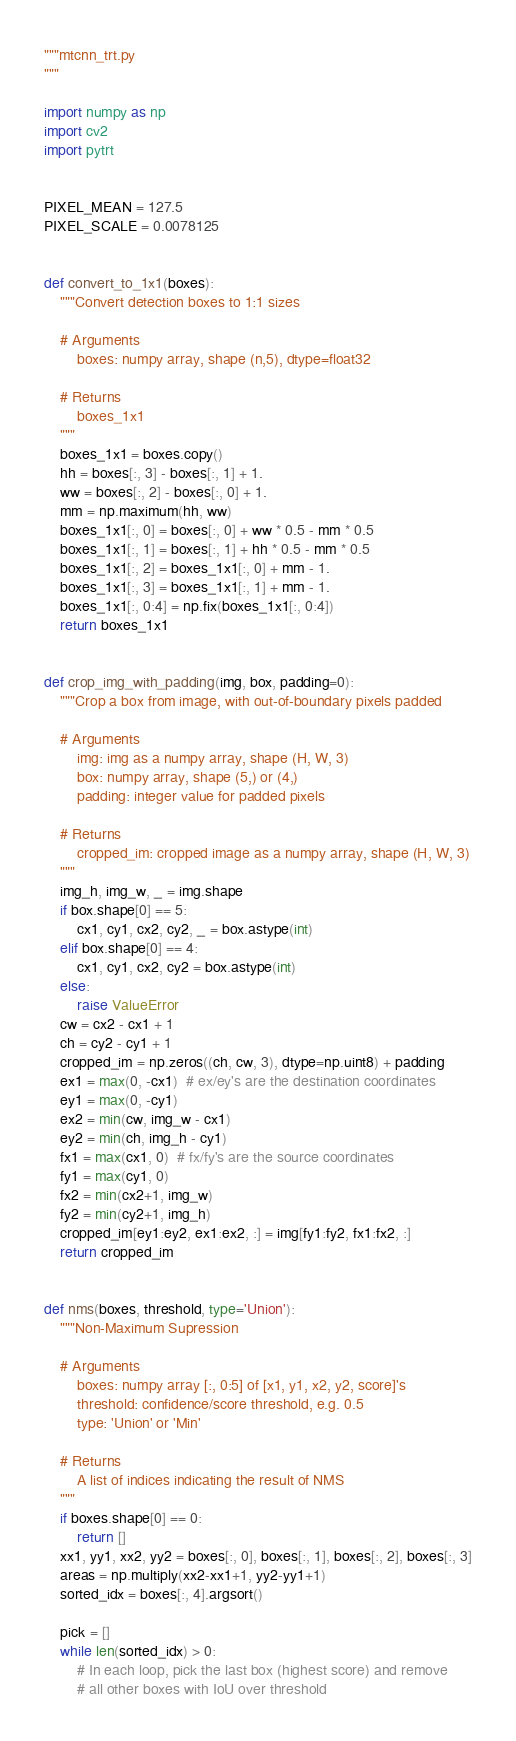Convert code to text. <code><loc_0><loc_0><loc_500><loc_500><_Python_>"""mtcnn_trt.py
"""

import numpy as np
import cv2
import pytrt


PIXEL_MEAN = 127.5
PIXEL_SCALE = 0.0078125


def convert_to_1x1(boxes):
    """Convert detection boxes to 1:1 sizes

    # Arguments
        boxes: numpy array, shape (n,5), dtype=float32

    # Returns
        boxes_1x1
    """
    boxes_1x1 = boxes.copy()
    hh = boxes[:, 3] - boxes[:, 1] + 1.
    ww = boxes[:, 2] - boxes[:, 0] + 1.
    mm = np.maximum(hh, ww)
    boxes_1x1[:, 0] = boxes[:, 0] + ww * 0.5 - mm * 0.5
    boxes_1x1[:, 1] = boxes[:, 1] + hh * 0.5 - mm * 0.5
    boxes_1x1[:, 2] = boxes_1x1[:, 0] + mm - 1.
    boxes_1x1[:, 3] = boxes_1x1[:, 1] + mm - 1.
    boxes_1x1[:, 0:4] = np.fix(boxes_1x1[:, 0:4])
    return boxes_1x1


def crop_img_with_padding(img, box, padding=0):
    """Crop a box from image, with out-of-boundary pixels padded

    # Arguments
        img: img as a numpy array, shape (H, W, 3)
        box: numpy array, shape (5,) or (4,)
        padding: integer value for padded pixels

    # Returns
        cropped_im: cropped image as a numpy array, shape (H, W, 3)
    """
    img_h, img_w, _ = img.shape
    if box.shape[0] == 5:
        cx1, cy1, cx2, cy2, _ = box.astype(int)
    elif box.shape[0] == 4:
        cx1, cy1, cx2, cy2 = box.astype(int)
    else:
        raise ValueError
    cw = cx2 - cx1 + 1
    ch = cy2 - cy1 + 1
    cropped_im = np.zeros((ch, cw, 3), dtype=np.uint8) + padding
    ex1 = max(0, -cx1)  # ex/ey's are the destination coordinates
    ey1 = max(0, -cy1)
    ex2 = min(cw, img_w - cx1)
    ey2 = min(ch, img_h - cy1)
    fx1 = max(cx1, 0)  # fx/fy's are the source coordinates
    fy1 = max(cy1, 0)
    fx2 = min(cx2+1, img_w)
    fy2 = min(cy2+1, img_h)
    cropped_im[ey1:ey2, ex1:ex2, :] = img[fy1:fy2, fx1:fx2, :]
    return cropped_im


def nms(boxes, threshold, type='Union'):
    """Non-Maximum Supression

    # Arguments
        boxes: numpy array [:, 0:5] of [x1, y1, x2, y2, score]'s
        threshold: confidence/score threshold, e.g. 0.5
        type: 'Union' or 'Min'

    # Returns
        A list of indices indicating the result of NMS
    """
    if boxes.shape[0] == 0:
        return []
    xx1, yy1, xx2, yy2 = boxes[:, 0], boxes[:, 1], boxes[:, 2], boxes[:, 3]
    areas = np.multiply(xx2-xx1+1, yy2-yy1+1)
    sorted_idx = boxes[:, 4].argsort()

    pick = []
    while len(sorted_idx) > 0:
        # In each loop, pick the last box (highest score) and remove
        # all other boxes with IoU over threshold</code> 